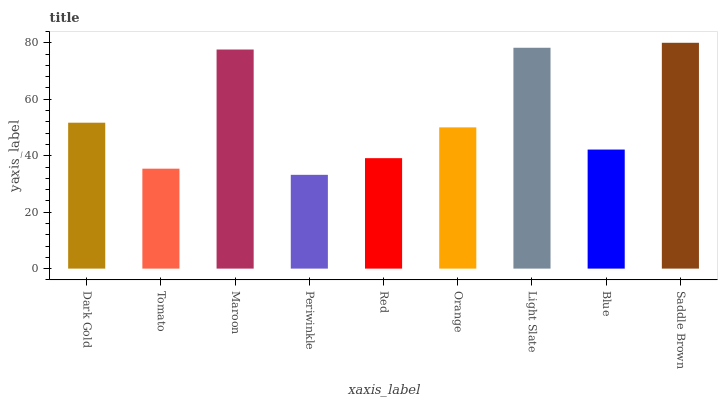Is Periwinkle the minimum?
Answer yes or no. Yes. Is Saddle Brown the maximum?
Answer yes or no. Yes. Is Tomato the minimum?
Answer yes or no. No. Is Tomato the maximum?
Answer yes or no. No. Is Dark Gold greater than Tomato?
Answer yes or no. Yes. Is Tomato less than Dark Gold?
Answer yes or no. Yes. Is Tomato greater than Dark Gold?
Answer yes or no. No. Is Dark Gold less than Tomato?
Answer yes or no. No. Is Orange the high median?
Answer yes or no. Yes. Is Orange the low median?
Answer yes or no. Yes. Is Tomato the high median?
Answer yes or no. No. Is Light Slate the low median?
Answer yes or no. No. 